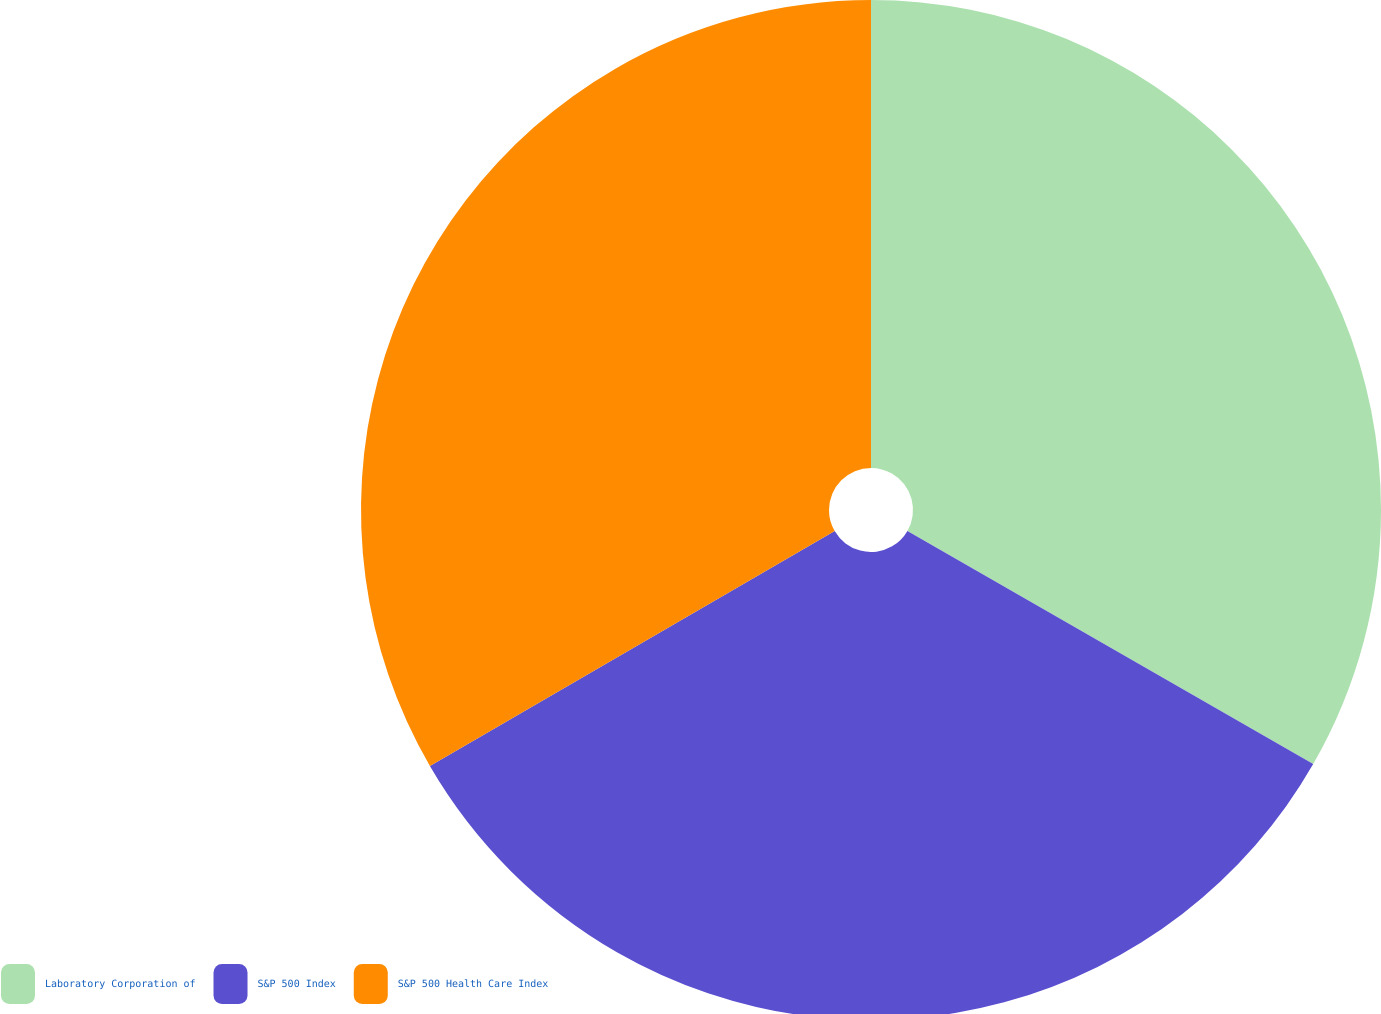Convert chart. <chart><loc_0><loc_0><loc_500><loc_500><pie_chart><fcel>Laboratory Corporation of<fcel>S&P 500 Index<fcel>S&P 500 Health Care Index<nl><fcel>33.3%<fcel>33.33%<fcel>33.37%<nl></chart> 